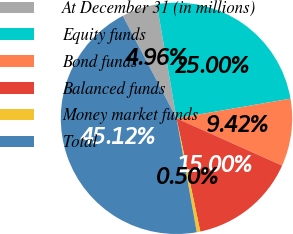<chart> <loc_0><loc_0><loc_500><loc_500><pie_chart><fcel>At December 31 (in millions)<fcel>Equity funds<fcel>Bond funds<fcel>Balanced funds<fcel>Money market funds<fcel>Total<nl><fcel>4.96%<fcel>25.0%<fcel>9.42%<fcel>15.0%<fcel>0.5%<fcel>45.12%<nl></chart> 